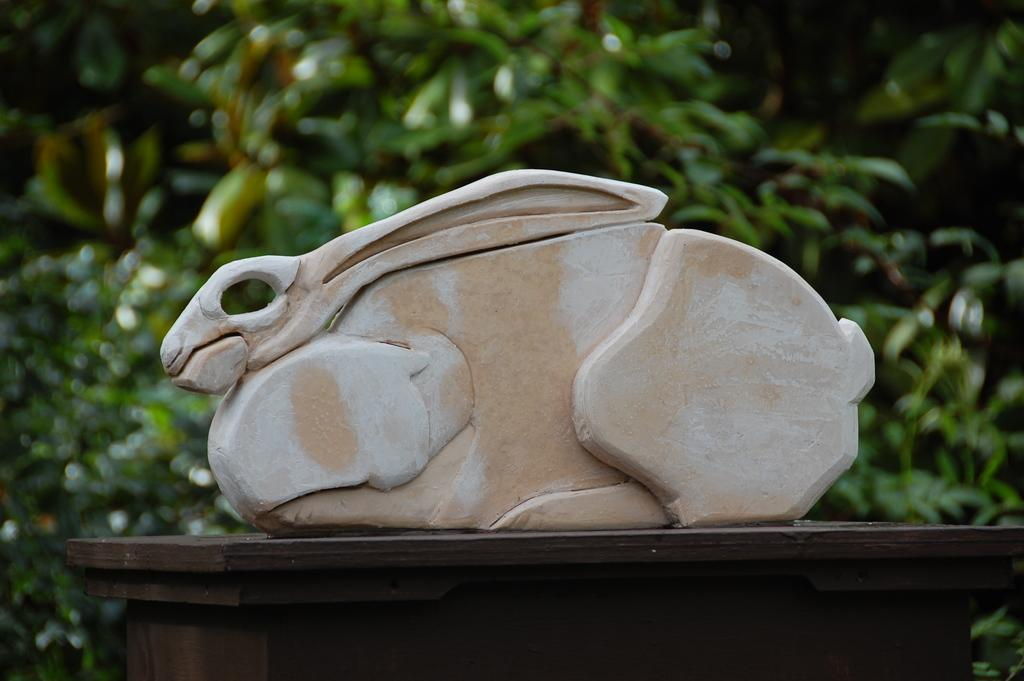What is the focus of the image? The image is a zoomed-in view of a sculpture of a rabbit. Where is the sculpture located? The sculpture is placed on top of a table. What can be seen in the background of the image? There are plants visible in the background of the image. How does the net help the rabbit in the image? There is no net present in the image, so it cannot help the rabbit. 